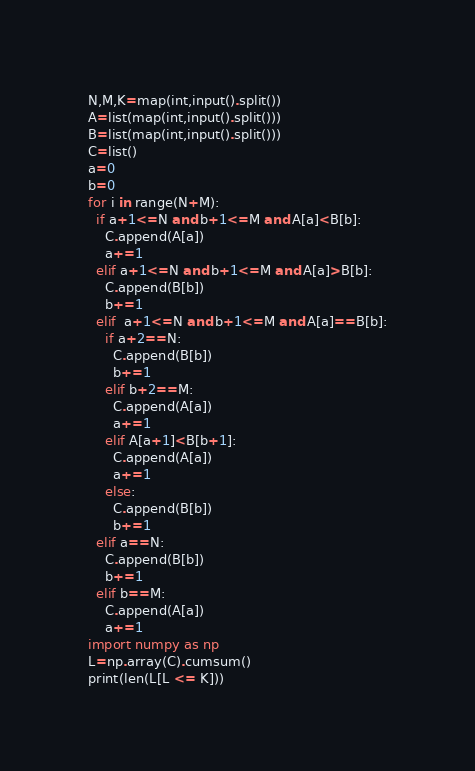Convert code to text. <code><loc_0><loc_0><loc_500><loc_500><_Python_>N,M,K=map(int,input().split())
A=list(map(int,input().split()))
B=list(map(int,input().split()))
C=list()
a=0
b=0
for i in range(N+M):
  if a+1<=N and b+1<=M and A[a]<B[b]:
    C.append(A[a])
    a+=1
  elif a+1<=N and b+1<=M and A[a]>B[b]:
    C.append(B[b])
    b+=1
  elif  a+1<=N and b+1<=M and A[a]==B[b]:
    if a+2==N:
      C.append(B[b])
      b+=1
    elif b+2==M:
      C.append(A[a])
      a+=1
    elif A[a+1]<B[b+1]:
      C.append(A[a])
      a+=1
    else:
      C.append(B[b])
      b+=1
  elif a==N:
    C.append(B[b])
    b+=1
  elif b==M:
    C.append(A[a])
    a+=1
import numpy as np
L=np.array(C).cumsum()
print(len(L[L <= K]))</code> 